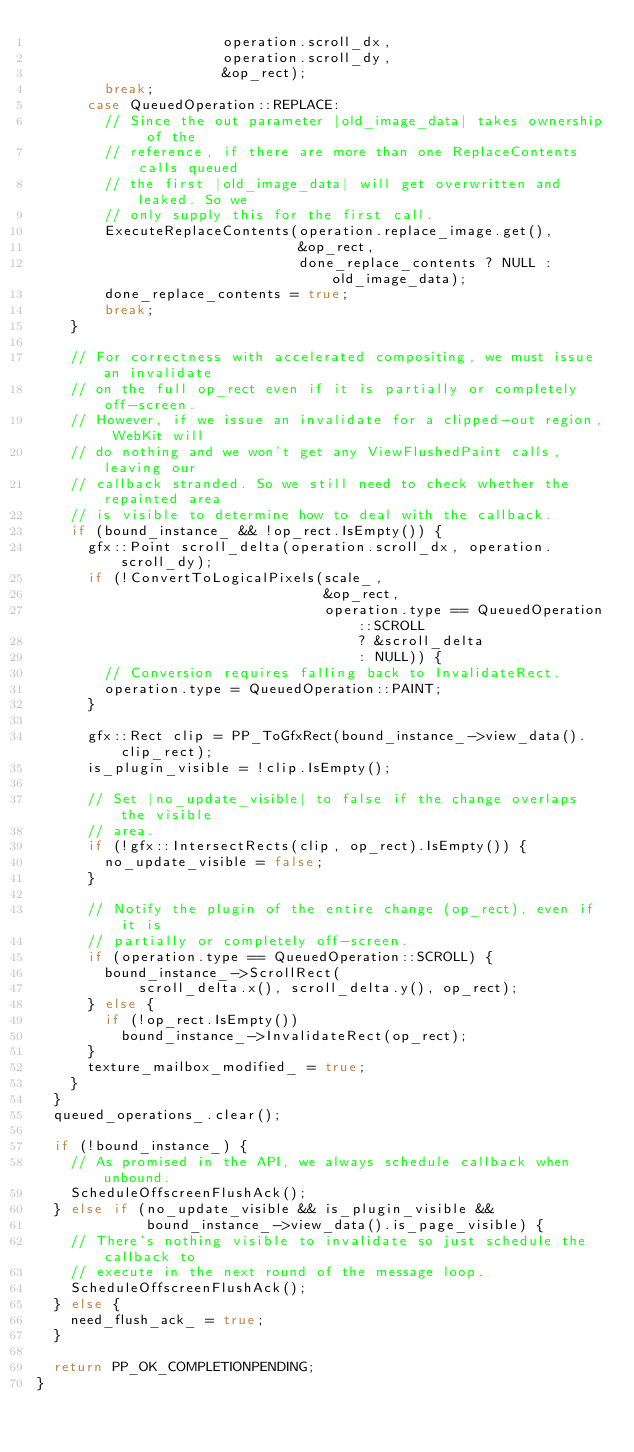Convert code to text. <code><loc_0><loc_0><loc_500><loc_500><_C++_>                      operation.scroll_dx,
                      operation.scroll_dy,
                      &op_rect);
        break;
      case QueuedOperation::REPLACE:
        // Since the out parameter |old_image_data| takes ownership of the
        // reference, if there are more than one ReplaceContents calls queued
        // the first |old_image_data| will get overwritten and leaked. So we
        // only supply this for the first call.
        ExecuteReplaceContents(operation.replace_image.get(),
                               &op_rect,
                               done_replace_contents ? NULL : old_image_data);
        done_replace_contents = true;
        break;
    }

    // For correctness with accelerated compositing, we must issue an invalidate
    // on the full op_rect even if it is partially or completely off-screen.
    // However, if we issue an invalidate for a clipped-out region, WebKit will
    // do nothing and we won't get any ViewFlushedPaint calls, leaving our
    // callback stranded. So we still need to check whether the repainted area
    // is visible to determine how to deal with the callback.
    if (bound_instance_ && !op_rect.IsEmpty()) {
      gfx::Point scroll_delta(operation.scroll_dx, operation.scroll_dy);
      if (!ConvertToLogicalPixels(scale_,
                                  &op_rect,
                                  operation.type == QueuedOperation::SCROLL
                                      ? &scroll_delta
                                      : NULL)) {
        // Conversion requires falling back to InvalidateRect.
        operation.type = QueuedOperation::PAINT;
      }

      gfx::Rect clip = PP_ToGfxRect(bound_instance_->view_data().clip_rect);
      is_plugin_visible = !clip.IsEmpty();

      // Set |no_update_visible| to false if the change overlaps the visible
      // area.
      if (!gfx::IntersectRects(clip, op_rect).IsEmpty()) {
        no_update_visible = false;
      }

      // Notify the plugin of the entire change (op_rect), even if it is
      // partially or completely off-screen.
      if (operation.type == QueuedOperation::SCROLL) {
        bound_instance_->ScrollRect(
            scroll_delta.x(), scroll_delta.y(), op_rect);
      } else {
        if (!op_rect.IsEmpty())
          bound_instance_->InvalidateRect(op_rect);
      }
      texture_mailbox_modified_ = true;
    }
  }
  queued_operations_.clear();

  if (!bound_instance_) {
    // As promised in the API, we always schedule callback when unbound.
    ScheduleOffscreenFlushAck();
  } else if (no_update_visible && is_plugin_visible &&
             bound_instance_->view_data().is_page_visible) {
    // There's nothing visible to invalidate so just schedule the callback to
    // execute in the next round of the message loop.
    ScheduleOffscreenFlushAck();
  } else {
    need_flush_ack_ = true;
  }

  return PP_OK_COMPLETIONPENDING;
}
</code> 